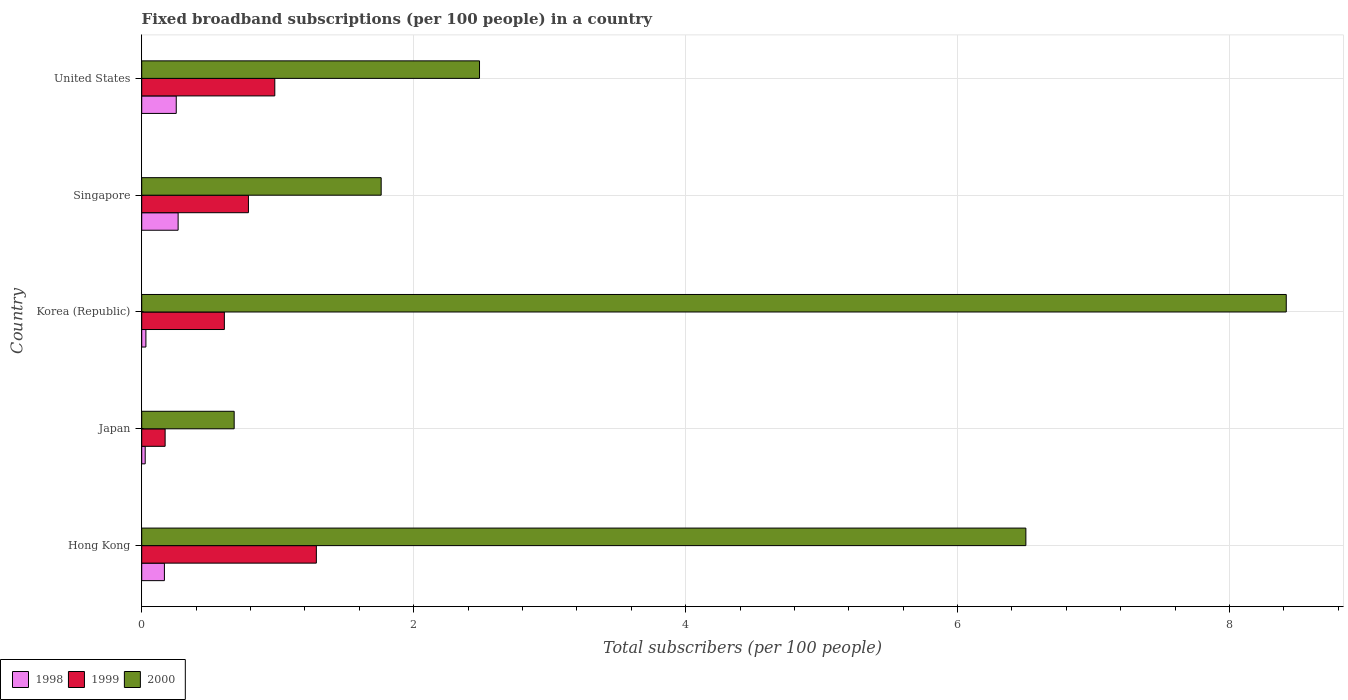How many different coloured bars are there?
Your response must be concise. 3. How many groups of bars are there?
Give a very brief answer. 5. Are the number of bars per tick equal to the number of legend labels?
Offer a terse response. Yes. How many bars are there on the 2nd tick from the bottom?
Your answer should be compact. 3. What is the label of the 2nd group of bars from the top?
Ensure brevity in your answer.  Singapore. In how many cases, is the number of bars for a given country not equal to the number of legend labels?
Provide a short and direct response. 0. What is the number of broadband subscriptions in 1999 in Singapore?
Provide a short and direct response. 0.78. Across all countries, what is the maximum number of broadband subscriptions in 1998?
Make the answer very short. 0.27. Across all countries, what is the minimum number of broadband subscriptions in 2000?
Provide a succinct answer. 0.68. What is the total number of broadband subscriptions in 1998 in the graph?
Offer a very short reply. 0.74. What is the difference between the number of broadband subscriptions in 1998 in Hong Kong and that in United States?
Keep it short and to the point. -0.09. What is the difference between the number of broadband subscriptions in 1998 in Singapore and the number of broadband subscriptions in 2000 in Hong Kong?
Make the answer very short. -6.23. What is the average number of broadband subscriptions in 1999 per country?
Give a very brief answer. 0.77. What is the difference between the number of broadband subscriptions in 1998 and number of broadband subscriptions in 1999 in Hong Kong?
Make the answer very short. -1.12. In how many countries, is the number of broadband subscriptions in 1999 greater than 6 ?
Your response must be concise. 0. What is the ratio of the number of broadband subscriptions in 2000 in Hong Kong to that in United States?
Your answer should be compact. 2.62. Is the difference between the number of broadband subscriptions in 1998 in Korea (Republic) and Singapore greater than the difference between the number of broadband subscriptions in 1999 in Korea (Republic) and Singapore?
Your response must be concise. No. What is the difference between the highest and the second highest number of broadband subscriptions in 1999?
Offer a terse response. 0.31. What is the difference between the highest and the lowest number of broadband subscriptions in 1998?
Offer a very short reply. 0.24. What does the 3rd bar from the top in United States represents?
Offer a very short reply. 1998. What does the 2nd bar from the bottom in Hong Kong represents?
Your answer should be compact. 1999. Is it the case that in every country, the sum of the number of broadband subscriptions in 1998 and number of broadband subscriptions in 2000 is greater than the number of broadband subscriptions in 1999?
Ensure brevity in your answer.  Yes. How many bars are there?
Provide a succinct answer. 15. How many countries are there in the graph?
Offer a terse response. 5. What is the difference between two consecutive major ticks on the X-axis?
Keep it short and to the point. 2. Does the graph contain any zero values?
Make the answer very short. No. Does the graph contain grids?
Make the answer very short. Yes. Where does the legend appear in the graph?
Make the answer very short. Bottom left. What is the title of the graph?
Keep it short and to the point. Fixed broadband subscriptions (per 100 people) in a country. Does "1988" appear as one of the legend labels in the graph?
Offer a very short reply. No. What is the label or title of the X-axis?
Make the answer very short. Total subscribers (per 100 people). What is the label or title of the Y-axis?
Give a very brief answer. Country. What is the Total subscribers (per 100 people) in 1998 in Hong Kong?
Offer a terse response. 0.17. What is the Total subscribers (per 100 people) in 1999 in Hong Kong?
Give a very brief answer. 1.28. What is the Total subscribers (per 100 people) in 2000 in Hong Kong?
Your answer should be very brief. 6.5. What is the Total subscribers (per 100 people) in 1998 in Japan?
Offer a terse response. 0.03. What is the Total subscribers (per 100 people) in 1999 in Japan?
Give a very brief answer. 0.17. What is the Total subscribers (per 100 people) in 2000 in Japan?
Give a very brief answer. 0.68. What is the Total subscribers (per 100 people) of 1998 in Korea (Republic)?
Your answer should be very brief. 0.03. What is the Total subscribers (per 100 people) of 1999 in Korea (Republic)?
Your answer should be compact. 0.61. What is the Total subscribers (per 100 people) in 2000 in Korea (Republic)?
Your response must be concise. 8.42. What is the Total subscribers (per 100 people) of 1998 in Singapore?
Your answer should be very brief. 0.27. What is the Total subscribers (per 100 people) of 1999 in Singapore?
Your answer should be compact. 0.78. What is the Total subscribers (per 100 people) in 2000 in Singapore?
Offer a terse response. 1.76. What is the Total subscribers (per 100 people) in 1998 in United States?
Ensure brevity in your answer.  0.25. What is the Total subscribers (per 100 people) of 1999 in United States?
Make the answer very short. 0.98. What is the Total subscribers (per 100 people) of 2000 in United States?
Give a very brief answer. 2.48. Across all countries, what is the maximum Total subscribers (per 100 people) in 1998?
Give a very brief answer. 0.27. Across all countries, what is the maximum Total subscribers (per 100 people) in 1999?
Make the answer very short. 1.28. Across all countries, what is the maximum Total subscribers (per 100 people) in 2000?
Ensure brevity in your answer.  8.42. Across all countries, what is the minimum Total subscribers (per 100 people) of 1998?
Provide a short and direct response. 0.03. Across all countries, what is the minimum Total subscribers (per 100 people) of 1999?
Keep it short and to the point. 0.17. Across all countries, what is the minimum Total subscribers (per 100 people) of 2000?
Your answer should be compact. 0.68. What is the total Total subscribers (per 100 people) of 1998 in the graph?
Provide a short and direct response. 0.74. What is the total Total subscribers (per 100 people) of 1999 in the graph?
Provide a short and direct response. 3.83. What is the total Total subscribers (per 100 people) of 2000 in the graph?
Your response must be concise. 19.84. What is the difference between the Total subscribers (per 100 people) in 1998 in Hong Kong and that in Japan?
Your answer should be very brief. 0.14. What is the difference between the Total subscribers (per 100 people) of 1999 in Hong Kong and that in Japan?
Your answer should be very brief. 1.11. What is the difference between the Total subscribers (per 100 people) of 2000 in Hong Kong and that in Japan?
Ensure brevity in your answer.  5.82. What is the difference between the Total subscribers (per 100 people) in 1998 in Hong Kong and that in Korea (Republic)?
Offer a terse response. 0.14. What is the difference between the Total subscribers (per 100 people) of 1999 in Hong Kong and that in Korea (Republic)?
Your response must be concise. 0.68. What is the difference between the Total subscribers (per 100 people) of 2000 in Hong Kong and that in Korea (Republic)?
Your answer should be compact. -1.91. What is the difference between the Total subscribers (per 100 people) of 1998 in Hong Kong and that in Singapore?
Offer a very short reply. -0.1. What is the difference between the Total subscribers (per 100 people) of 1999 in Hong Kong and that in Singapore?
Give a very brief answer. 0.5. What is the difference between the Total subscribers (per 100 people) in 2000 in Hong Kong and that in Singapore?
Offer a terse response. 4.74. What is the difference between the Total subscribers (per 100 people) of 1998 in Hong Kong and that in United States?
Make the answer very short. -0.09. What is the difference between the Total subscribers (per 100 people) of 1999 in Hong Kong and that in United States?
Keep it short and to the point. 0.31. What is the difference between the Total subscribers (per 100 people) in 2000 in Hong Kong and that in United States?
Make the answer very short. 4.02. What is the difference between the Total subscribers (per 100 people) of 1998 in Japan and that in Korea (Republic)?
Your response must be concise. -0.01. What is the difference between the Total subscribers (per 100 people) in 1999 in Japan and that in Korea (Republic)?
Make the answer very short. -0.44. What is the difference between the Total subscribers (per 100 people) in 2000 in Japan and that in Korea (Republic)?
Provide a short and direct response. -7.74. What is the difference between the Total subscribers (per 100 people) of 1998 in Japan and that in Singapore?
Your response must be concise. -0.24. What is the difference between the Total subscribers (per 100 people) in 1999 in Japan and that in Singapore?
Your answer should be compact. -0.61. What is the difference between the Total subscribers (per 100 people) of 2000 in Japan and that in Singapore?
Provide a short and direct response. -1.08. What is the difference between the Total subscribers (per 100 people) in 1998 in Japan and that in United States?
Provide a succinct answer. -0.23. What is the difference between the Total subscribers (per 100 people) of 1999 in Japan and that in United States?
Provide a succinct answer. -0.81. What is the difference between the Total subscribers (per 100 people) in 2000 in Japan and that in United States?
Ensure brevity in your answer.  -1.8. What is the difference between the Total subscribers (per 100 people) in 1998 in Korea (Republic) and that in Singapore?
Offer a terse response. -0.24. What is the difference between the Total subscribers (per 100 people) in 1999 in Korea (Republic) and that in Singapore?
Offer a terse response. -0.18. What is the difference between the Total subscribers (per 100 people) of 2000 in Korea (Republic) and that in Singapore?
Your response must be concise. 6.66. What is the difference between the Total subscribers (per 100 people) in 1998 in Korea (Republic) and that in United States?
Provide a short and direct response. -0.22. What is the difference between the Total subscribers (per 100 people) in 1999 in Korea (Republic) and that in United States?
Provide a short and direct response. -0.37. What is the difference between the Total subscribers (per 100 people) in 2000 in Korea (Republic) and that in United States?
Give a very brief answer. 5.93. What is the difference between the Total subscribers (per 100 people) in 1998 in Singapore and that in United States?
Offer a terse response. 0.01. What is the difference between the Total subscribers (per 100 people) in 1999 in Singapore and that in United States?
Offer a terse response. -0.19. What is the difference between the Total subscribers (per 100 people) in 2000 in Singapore and that in United States?
Provide a short and direct response. -0.72. What is the difference between the Total subscribers (per 100 people) in 1998 in Hong Kong and the Total subscribers (per 100 people) in 1999 in Japan?
Provide a succinct answer. -0.01. What is the difference between the Total subscribers (per 100 people) in 1998 in Hong Kong and the Total subscribers (per 100 people) in 2000 in Japan?
Make the answer very short. -0.51. What is the difference between the Total subscribers (per 100 people) of 1999 in Hong Kong and the Total subscribers (per 100 people) of 2000 in Japan?
Provide a short and direct response. 0.6. What is the difference between the Total subscribers (per 100 people) in 1998 in Hong Kong and the Total subscribers (per 100 people) in 1999 in Korea (Republic)?
Your answer should be compact. -0.44. What is the difference between the Total subscribers (per 100 people) of 1998 in Hong Kong and the Total subscribers (per 100 people) of 2000 in Korea (Republic)?
Ensure brevity in your answer.  -8.25. What is the difference between the Total subscribers (per 100 people) in 1999 in Hong Kong and the Total subscribers (per 100 people) in 2000 in Korea (Republic)?
Make the answer very short. -7.13. What is the difference between the Total subscribers (per 100 people) in 1998 in Hong Kong and the Total subscribers (per 100 people) in 1999 in Singapore?
Your answer should be very brief. -0.62. What is the difference between the Total subscribers (per 100 people) of 1998 in Hong Kong and the Total subscribers (per 100 people) of 2000 in Singapore?
Keep it short and to the point. -1.59. What is the difference between the Total subscribers (per 100 people) in 1999 in Hong Kong and the Total subscribers (per 100 people) in 2000 in Singapore?
Your answer should be compact. -0.48. What is the difference between the Total subscribers (per 100 people) in 1998 in Hong Kong and the Total subscribers (per 100 people) in 1999 in United States?
Offer a terse response. -0.81. What is the difference between the Total subscribers (per 100 people) of 1998 in Hong Kong and the Total subscribers (per 100 people) of 2000 in United States?
Your answer should be compact. -2.32. What is the difference between the Total subscribers (per 100 people) of 1999 in Hong Kong and the Total subscribers (per 100 people) of 2000 in United States?
Offer a terse response. -1.2. What is the difference between the Total subscribers (per 100 people) of 1998 in Japan and the Total subscribers (per 100 people) of 1999 in Korea (Republic)?
Keep it short and to the point. -0.58. What is the difference between the Total subscribers (per 100 people) in 1998 in Japan and the Total subscribers (per 100 people) in 2000 in Korea (Republic)?
Provide a short and direct response. -8.39. What is the difference between the Total subscribers (per 100 people) in 1999 in Japan and the Total subscribers (per 100 people) in 2000 in Korea (Republic)?
Your answer should be compact. -8.25. What is the difference between the Total subscribers (per 100 people) in 1998 in Japan and the Total subscribers (per 100 people) in 1999 in Singapore?
Your answer should be very brief. -0.76. What is the difference between the Total subscribers (per 100 people) of 1998 in Japan and the Total subscribers (per 100 people) of 2000 in Singapore?
Make the answer very short. -1.74. What is the difference between the Total subscribers (per 100 people) of 1999 in Japan and the Total subscribers (per 100 people) of 2000 in Singapore?
Provide a succinct answer. -1.59. What is the difference between the Total subscribers (per 100 people) in 1998 in Japan and the Total subscribers (per 100 people) in 1999 in United States?
Provide a succinct answer. -0.95. What is the difference between the Total subscribers (per 100 people) in 1998 in Japan and the Total subscribers (per 100 people) in 2000 in United States?
Provide a succinct answer. -2.46. What is the difference between the Total subscribers (per 100 people) of 1999 in Japan and the Total subscribers (per 100 people) of 2000 in United States?
Provide a succinct answer. -2.31. What is the difference between the Total subscribers (per 100 people) in 1998 in Korea (Republic) and the Total subscribers (per 100 people) in 1999 in Singapore?
Make the answer very short. -0.75. What is the difference between the Total subscribers (per 100 people) in 1998 in Korea (Republic) and the Total subscribers (per 100 people) in 2000 in Singapore?
Ensure brevity in your answer.  -1.73. What is the difference between the Total subscribers (per 100 people) of 1999 in Korea (Republic) and the Total subscribers (per 100 people) of 2000 in Singapore?
Make the answer very short. -1.15. What is the difference between the Total subscribers (per 100 people) in 1998 in Korea (Republic) and the Total subscribers (per 100 people) in 1999 in United States?
Your answer should be compact. -0.95. What is the difference between the Total subscribers (per 100 people) in 1998 in Korea (Republic) and the Total subscribers (per 100 people) in 2000 in United States?
Offer a terse response. -2.45. What is the difference between the Total subscribers (per 100 people) in 1999 in Korea (Republic) and the Total subscribers (per 100 people) in 2000 in United States?
Provide a short and direct response. -1.88. What is the difference between the Total subscribers (per 100 people) of 1998 in Singapore and the Total subscribers (per 100 people) of 1999 in United States?
Keep it short and to the point. -0.71. What is the difference between the Total subscribers (per 100 people) in 1998 in Singapore and the Total subscribers (per 100 people) in 2000 in United States?
Keep it short and to the point. -2.22. What is the difference between the Total subscribers (per 100 people) of 1999 in Singapore and the Total subscribers (per 100 people) of 2000 in United States?
Keep it short and to the point. -1.7. What is the average Total subscribers (per 100 people) in 1998 per country?
Provide a short and direct response. 0.15. What is the average Total subscribers (per 100 people) of 1999 per country?
Make the answer very short. 0.77. What is the average Total subscribers (per 100 people) in 2000 per country?
Your answer should be very brief. 3.97. What is the difference between the Total subscribers (per 100 people) in 1998 and Total subscribers (per 100 people) in 1999 in Hong Kong?
Your answer should be compact. -1.12. What is the difference between the Total subscribers (per 100 people) of 1998 and Total subscribers (per 100 people) of 2000 in Hong Kong?
Make the answer very short. -6.34. What is the difference between the Total subscribers (per 100 people) of 1999 and Total subscribers (per 100 people) of 2000 in Hong Kong?
Give a very brief answer. -5.22. What is the difference between the Total subscribers (per 100 people) of 1998 and Total subscribers (per 100 people) of 1999 in Japan?
Your answer should be compact. -0.15. What is the difference between the Total subscribers (per 100 people) of 1998 and Total subscribers (per 100 people) of 2000 in Japan?
Offer a very short reply. -0.65. What is the difference between the Total subscribers (per 100 people) in 1999 and Total subscribers (per 100 people) in 2000 in Japan?
Your answer should be very brief. -0.51. What is the difference between the Total subscribers (per 100 people) of 1998 and Total subscribers (per 100 people) of 1999 in Korea (Republic)?
Your answer should be compact. -0.58. What is the difference between the Total subscribers (per 100 people) in 1998 and Total subscribers (per 100 people) in 2000 in Korea (Republic)?
Provide a short and direct response. -8.39. What is the difference between the Total subscribers (per 100 people) in 1999 and Total subscribers (per 100 people) in 2000 in Korea (Republic)?
Make the answer very short. -7.81. What is the difference between the Total subscribers (per 100 people) of 1998 and Total subscribers (per 100 people) of 1999 in Singapore?
Your answer should be very brief. -0.52. What is the difference between the Total subscribers (per 100 people) in 1998 and Total subscribers (per 100 people) in 2000 in Singapore?
Provide a succinct answer. -1.49. What is the difference between the Total subscribers (per 100 people) of 1999 and Total subscribers (per 100 people) of 2000 in Singapore?
Offer a terse response. -0.98. What is the difference between the Total subscribers (per 100 people) of 1998 and Total subscribers (per 100 people) of 1999 in United States?
Keep it short and to the point. -0.72. What is the difference between the Total subscribers (per 100 people) in 1998 and Total subscribers (per 100 people) in 2000 in United States?
Provide a succinct answer. -2.23. What is the difference between the Total subscribers (per 100 people) of 1999 and Total subscribers (per 100 people) of 2000 in United States?
Provide a succinct answer. -1.51. What is the ratio of the Total subscribers (per 100 people) of 1998 in Hong Kong to that in Japan?
Make the answer very short. 6.53. What is the ratio of the Total subscribers (per 100 people) in 1999 in Hong Kong to that in Japan?
Make the answer very short. 7.46. What is the ratio of the Total subscribers (per 100 people) in 2000 in Hong Kong to that in Japan?
Your response must be concise. 9.56. What is the ratio of the Total subscribers (per 100 people) in 1998 in Hong Kong to that in Korea (Republic)?
Make the answer very short. 5.42. What is the ratio of the Total subscribers (per 100 people) in 1999 in Hong Kong to that in Korea (Republic)?
Keep it short and to the point. 2.11. What is the ratio of the Total subscribers (per 100 people) of 2000 in Hong Kong to that in Korea (Republic)?
Provide a succinct answer. 0.77. What is the ratio of the Total subscribers (per 100 people) of 1998 in Hong Kong to that in Singapore?
Ensure brevity in your answer.  0.62. What is the ratio of the Total subscribers (per 100 people) in 1999 in Hong Kong to that in Singapore?
Give a very brief answer. 1.64. What is the ratio of the Total subscribers (per 100 people) of 2000 in Hong Kong to that in Singapore?
Ensure brevity in your answer.  3.69. What is the ratio of the Total subscribers (per 100 people) of 1998 in Hong Kong to that in United States?
Keep it short and to the point. 0.66. What is the ratio of the Total subscribers (per 100 people) of 1999 in Hong Kong to that in United States?
Provide a short and direct response. 1.31. What is the ratio of the Total subscribers (per 100 people) in 2000 in Hong Kong to that in United States?
Provide a short and direct response. 2.62. What is the ratio of the Total subscribers (per 100 people) of 1998 in Japan to that in Korea (Republic)?
Your answer should be very brief. 0.83. What is the ratio of the Total subscribers (per 100 people) of 1999 in Japan to that in Korea (Republic)?
Make the answer very short. 0.28. What is the ratio of the Total subscribers (per 100 people) of 2000 in Japan to that in Korea (Republic)?
Your answer should be very brief. 0.08. What is the ratio of the Total subscribers (per 100 people) in 1998 in Japan to that in Singapore?
Provide a short and direct response. 0.1. What is the ratio of the Total subscribers (per 100 people) in 1999 in Japan to that in Singapore?
Your answer should be compact. 0.22. What is the ratio of the Total subscribers (per 100 people) of 2000 in Japan to that in Singapore?
Your answer should be compact. 0.39. What is the ratio of the Total subscribers (per 100 people) in 1998 in Japan to that in United States?
Keep it short and to the point. 0.1. What is the ratio of the Total subscribers (per 100 people) of 1999 in Japan to that in United States?
Your answer should be very brief. 0.18. What is the ratio of the Total subscribers (per 100 people) in 2000 in Japan to that in United States?
Offer a terse response. 0.27. What is the ratio of the Total subscribers (per 100 people) in 1998 in Korea (Republic) to that in Singapore?
Your answer should be compact. 0.12. What is the ratio of the Total subscribers (per 100 people) of 1999 in Korea (Republic) to that in Singapore?
Your answer should be compact. 0.77. What is the ratio of the Total subscribers (per 100 people) in 2000 in Korea (Republic) to that in Singapore?
Provide a succinct answer. 4.78. What is the ratio of the Total subscribers (per 100 people) of 1998 in Korea (Republic) to that in United States?
Offer a terse response. 0.12. What is the ratio of the Total subscribers (per 100 people) of 1999 in Korea (Republic) to that in United States?
Give a very brief answer. 0.62. What is the ratio of the Total subscribers (per 100 people) in 2000 in Korea (Republic) to that in United States?
Give a very brief answer. 3.39. What is the ratio of the Total subscribers (per 100 people) of 1998 in Singapore to that in United States?
Your answer should be very brief. 1.05. What is the ratio of the Total subscribers (per 100 people) in 1999 in Singapore to that in United States?
Make the answer very short. 0.8. What is the ratio of the Total subscribers (per 100 people) in 2000 in Singapore to that in United States?
Your response must be concise. 0.71. What is the difference between the highest and the second highest Total subscribers (per 100 people) in 1998?
Give a very brief answer. 0.01. What is the difference between the highest and the second highest Total subscribers (per 100 people) of 1999?
Make the answer very short. 0.31. What is the difference between the highest and the second highest Total subscribers (per 100 people) of 2000?
Provide a succinct answer. 1.91. What is the difference between the highest and the lowest Total subscribers (per 100 people) in 1998?
Offer a very short reply. 0.24. What is the difference between the highest and the lowest Total subscribers (per 100 people) in 1999?
Keep it short and to the point. 1.11. What is the difference between the highest and the lowest Total subscribers (per 100 people) of 2000?
Your answer should be very brief. 7.74. 